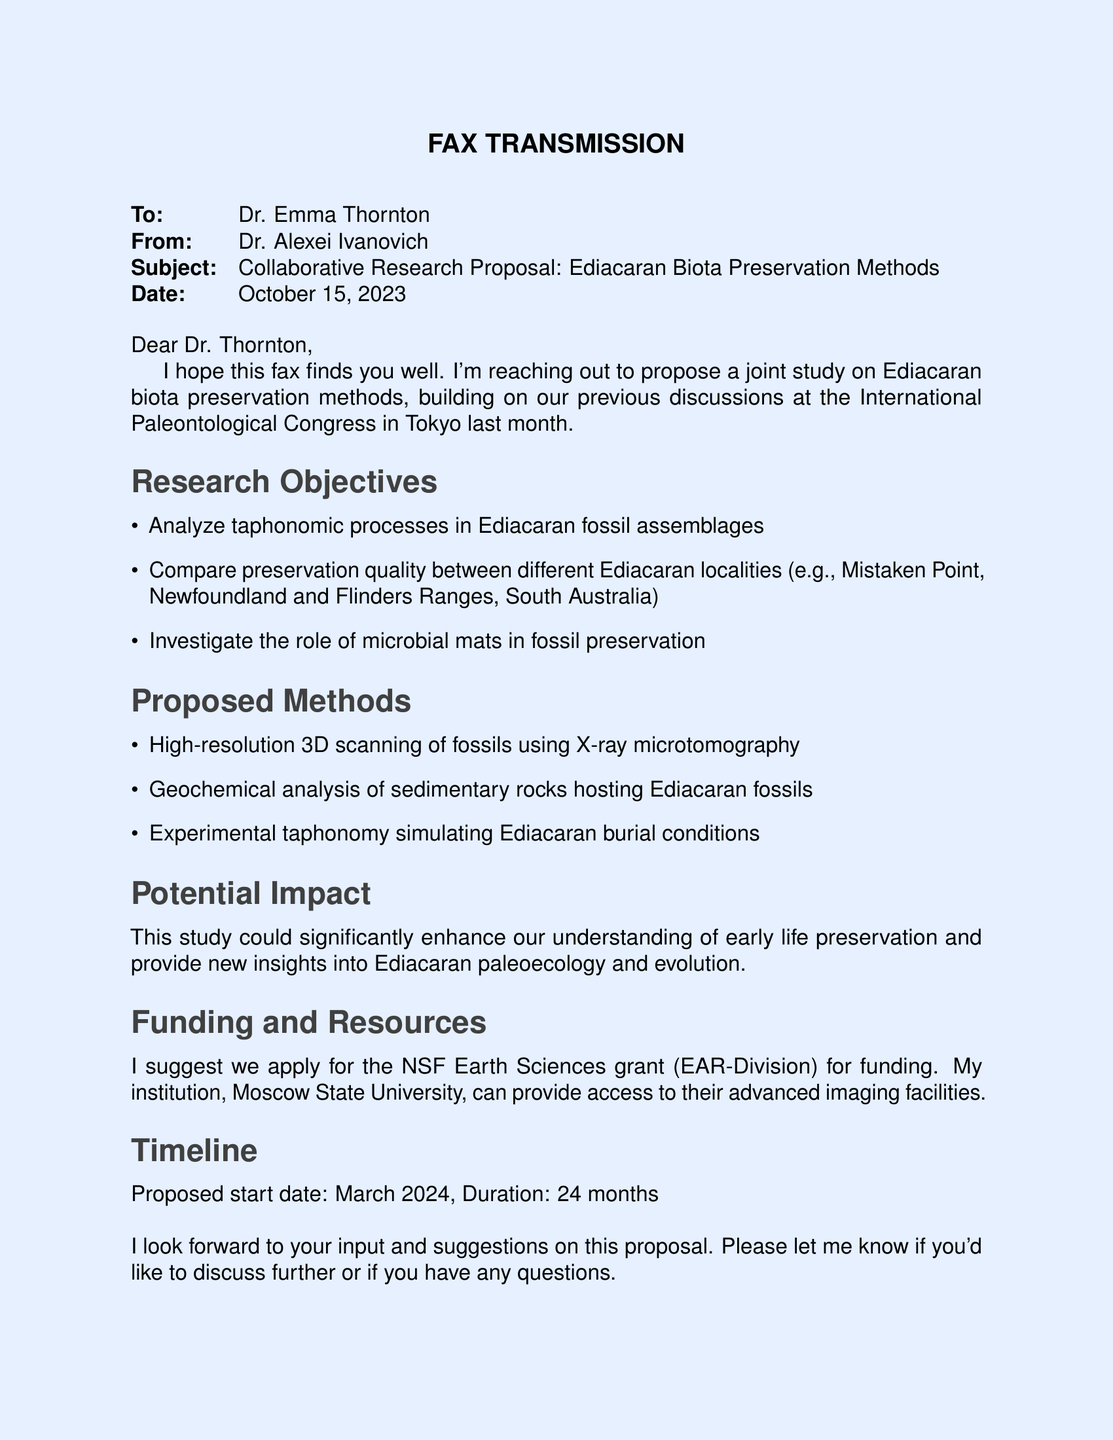What is the subject of the fax? The subject is mentioned in the "Subject" line of the fax, summarizing the purpose of the communication.
Answer: Collaborative Research Proposal: Ediacaran Biota Preservation Methods Who is the sender of the fax? The sender's information is given at the beginning of the document, listing their name and title.
Answer: Dr. Alexei Ivanovich What is the proposed start date of the research? The start date is clearly stated in the "Timeline" section of the document.
Answer: March 2024 How long is the duration of the proposed study? The duration is specified in the "Timeline" section, providing information on how long the project is expected to last.
Answer: 24 months What specific analysis method is proposed for studying Ediacaran fossils? The document lists the methods proposed in the "Proposed Methods" section.
Answer: High-resolution 3D scanning Which grant is suggested for funding? The funding source is mentioned in the "Funding and Resources" section of the document.
Answer: NSF Earth Sciences grant (EAR-Division) What role do microbial mats play in this research proposal? This information is included in the "Research Objectives" section, detailing what the study intends to investigate.
Answer: Investigate the role of microbial mats in fossil preservation What is the main aim of the proposed study? The major aim is summarized under "Potential Impact," indicating the overall goal of the research.
Answer: Enhance understanding of early life preservation Who is the recipient of the fax? The recipient's details are provided at the top of the fax, indicating to whom the communication is directed.
Answer: Dr. Emma Thornton 